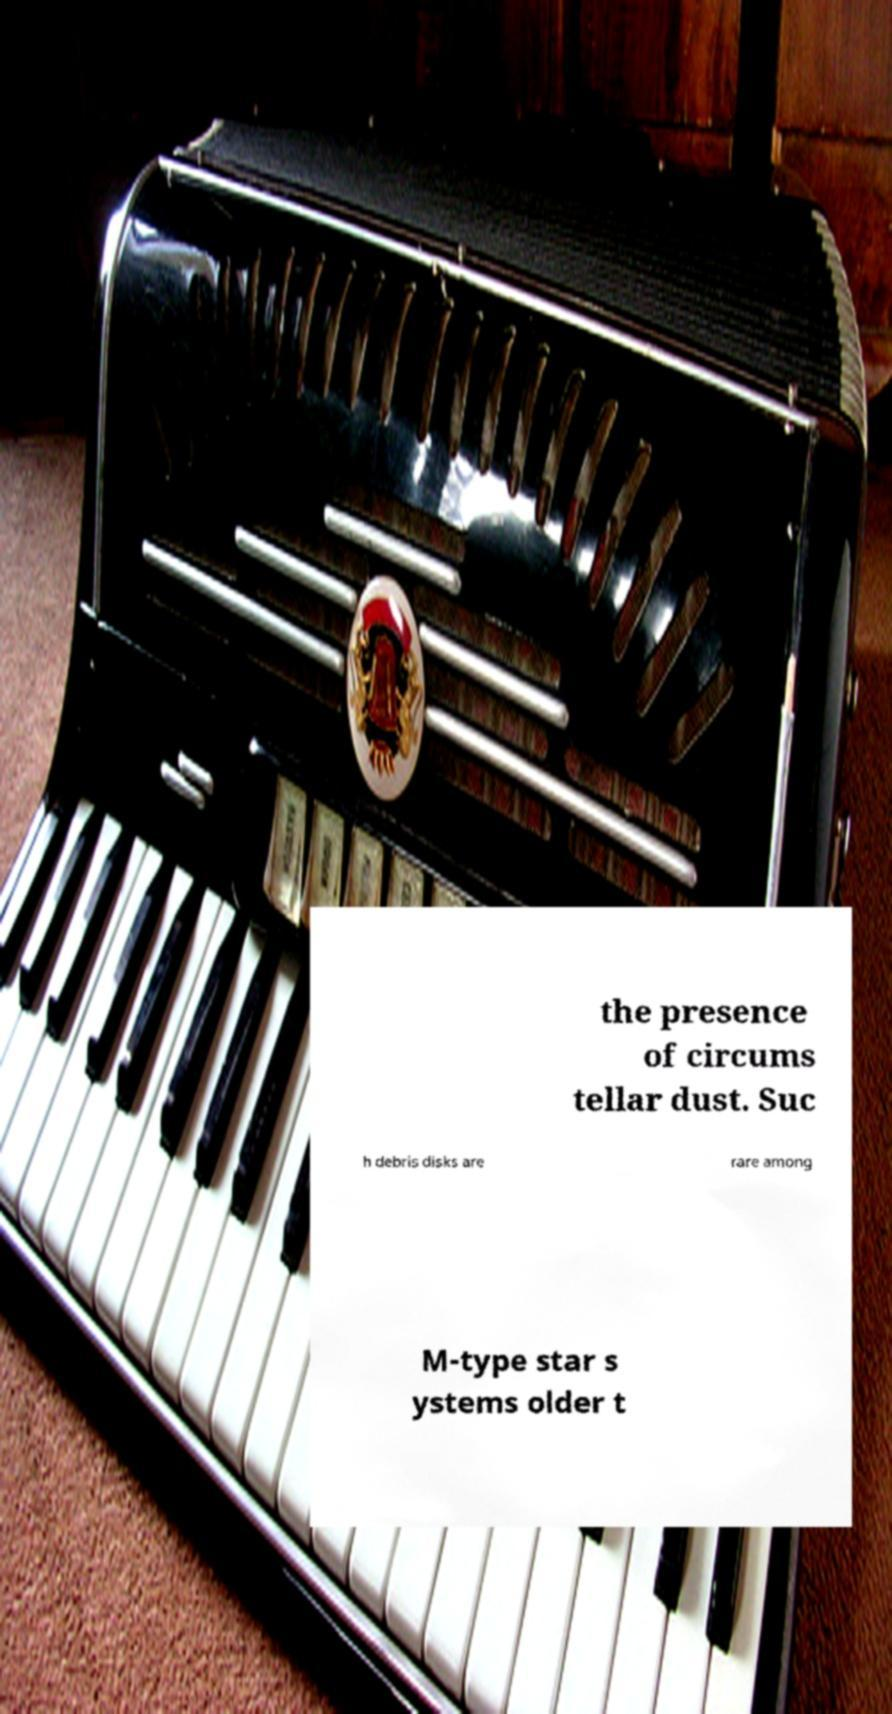Could you extract and type out the text from this image? the presence of circums tellar dust. Suc h debris disks are rare among M-type star s ystems older t 